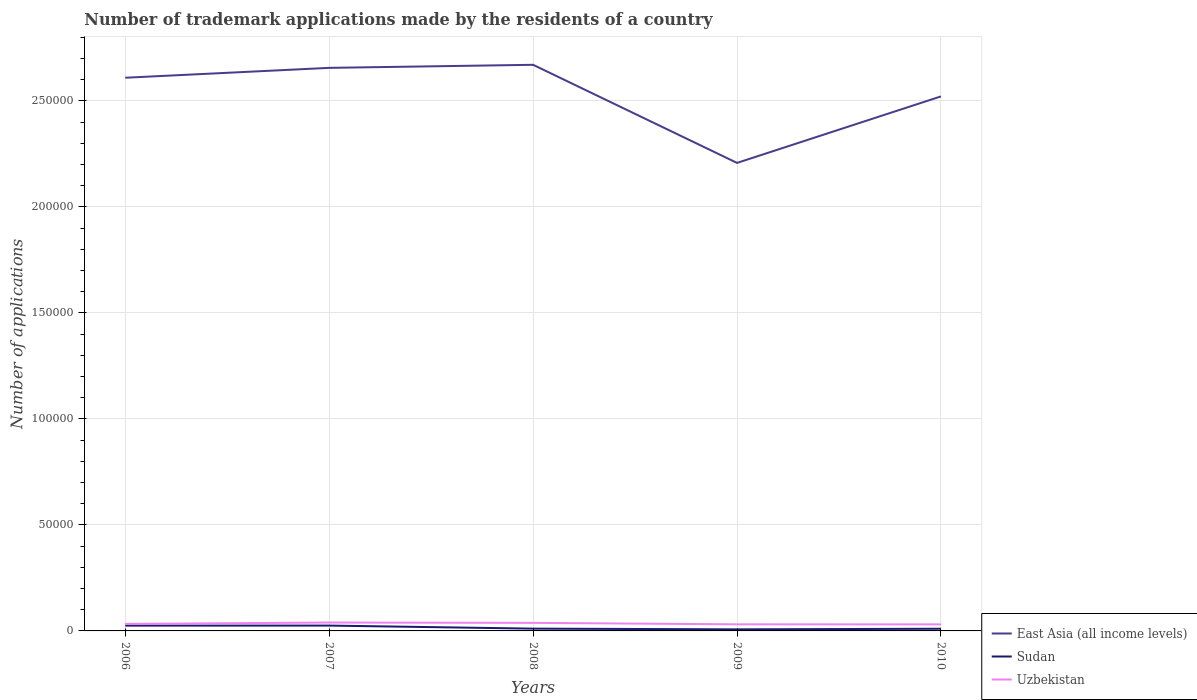Is the number of lines equal to the number of legend labels?
Your answer should be very brief. Yes. Across all years, what is the maximum number of trademark applications made by the residents in Sudan?
Make the answer very short. 743. What is the difference between the highest and the second highest number of trademark applications made by the residents in East Asia (all income levels)?
Ensure brevity in your answer.  4.63e+04. What is the difference between the highest and the lowest number of trademark applications made by the residents in Sudan?
Ensure brevity in your answer.  2. Is the number of trademark applications made by the residents in Sudan strictly greater than the number of trademark applications made by the residents in East Asia (all income levels) over the years?
Offer a terse response. Yes. How many lines are there?
Offer a very short reply. 3. How many years are there in the graph?
Keep it short and to the point. 5. What is the difference between two consecutive major ticks on the Y-axis?
Provide a short and direct response. 5.00e+04. Does the graph contain any zero values?
Your response must be concise. No. Does the graph contain grids?
Your answer should be compact. Yes. Where does the legend appear in the graph?
Offer a very short reply. Bottom right. What is the title of the graph?
Your answer should be very brief. Number of trademark applications made by the residents of a country. Does "Low income" appear as one of the legend labels in the graph?
Keep it short and to the point. No. What is the label or title of the X-axis?
Offer a terse response. Years. What is the label or title of the Y-axis?
Your answer should be very brief. Number of applications. What is the Number of applications of East Asia (all income levels) in 2006?
Keep it short and to the point. 2.61e+05. What is the Number of applications of Sudan in 2006?
Your answer should be compact. 2508. What is the Number of applications in Uzbekistan in 2006?
Provide a short and direct response. 3309. What is the Number of applications in East Asia (all income levels) in 2007?
Keep it short and to the point. 2.66e+05. What is the Number of applications in Sudan in 2007?
Your response must be concise. 2517. What is the Number of applications of Uzbekistan in 2007?
Your answer should be very brief. 3948. What is the Number of applications in East Asia (all income levels) in 2008?
Offer a terse response. 2.67e+05. What is the Number of applications of Sudan in 2008?
Your answer should be very brief. 1075. What is the Number of applications in Uzbekistan in 2008?
Provide a succinct answer. 3803. What is the Number of applications in East Asia (all income levels) in 2009?
Keep it short and to the point. 2.21e+05. What is the Number of applications in Sudan in 2009?
Keep it short and to the point. 743. What is the Number of applications of Uzbekistan in 2009?
Give a very brief answer. 3110. What is the Number of applications of East Asia (all income levels) in 2010?
Give a very brief answer. 2.52e+05. What is the Number of applications of Sudan in 2010?
Offer a terse response. 1025. What is the Number of applications in Uzbekistan in 2010?
Ensure brevity in your answer.  3088. Across all years, what is the maximum Number of applications of East Asia (all income levels)?
Provide a short and direct response. 2.67e+05. Across all years, what is the maximum Number of applications in Sudan?
Your answer should be very brief. 2517. Across all years, what is the maximum Number of applications of Uzbekistan?
Make the answer very short. 3948. Across all years, what is the minimum Number of applications of East Asia (all income levels)?
Provide a succinct answer. 2.21e+05. Across all years, what is the minimum Number of applications in Sudan?
Make the answer very short. 743. Across all years, what is the minimum Number of applications of Uzbekistan?
Keep it short and to the point. 3088. What is the total Number of applications in East Asia (all income levels) in the graph?
Your response must be concise. 1.27e+06. What is the total Number of applications of Sudan in the graph?
Your answer should be very brief. 7868. What is the total Number of applications of Uzbekistan in the graph?
Ensure brevity in your answer.  1.73e+04. What is the difference between the Number of applications of East Asia (all income levels) in 2006 and that in 2007?
Your response must be concise. -4664. What is the difference between the Number of applications in Sudan in 2006 and that in 2007?
Your answer should be very brief. -9. What is the difference between the Number of applications in Uzbekistan in 2006 and that in 2007?
Ensure brevity in your answer.  -639. What is the difference between the Number of applications of East Asia (all income levels) in 2006 and that in 2008?
Ensure brevity in your answer.  -6103. What is the difference between the Number of applications in Sudan in 2006 and that in 2008?
Ensure brevity in your answer.  1433. What is the difference between the Number of applications in Uzbekistan in 2006 and that in 2008?
Provide a short and direct response. -494. What is the difference between the Number of applications in East Asia (all income levels) in 2006 and that in 2009?
Ensure brevity in your answer.  4.02e+04. What is the difference between the Number of applications in Sudan in 2006 and that in 2009?
Offer a terse response. 1765. What is the difference between the Number of applications in Uzbekistan in 2006 and that in 2009?
Keep it short and to the point. 199. What is the difference between the Number of applications in East Asia (all income levels) in 2006 and that in 2010?
Give a very brief answer. 8800. What is the difference between the Number of applications in Sudan in 2006 and that in 2010?
Your response must be concise. 1483. What is the difference between the Number of applications of Uzbekistan in 2006 and that in 2010?
Provide a succinct answer. 221. What is the difference between the Number of applications in East Asia (all income levels) in 2007 and that in 2008?
Your answer should be compact. -1439. What is the difference between the Number of applications of Sudan in 2007 and that in 2008?
Offer a terse response. 1442. What is the difference between the Number of applications in Uzbekistan in 2007 and that in 2008?
Make the answer very short. 145. What is the difference between the Number of applications in East Asia (all income levels) in 2007 and that in 2009?
Your response must be concise. 4.48e+04. What is the difference between the Number of applications of Sudan in 2007 and that in 2009?
Your response must be concise. 1774. What is the difference between the Number of applications of Uzbekistan in 2007 and that in 2009?
Offer a very short reply. 838. What is the difference between the Number of applications in East Asia (all income levels) in 2007 and that in 2010?
Ensure brevity in your answer.  1.35e+04. What is the difference between the Number of applications of Sudan in 2007 and that in 2010?
Your answer should be very brief. 1492. What is the difference between the Number of applications of Uzbekistan in 2007 and that in 2010?
Provide a succinct answer. 860. What is the difference between the Number of applications in East Asia (all income levels) in 2008 and that in 2009?
Your response must be concise. 4.63e+04. What is the difference between the Number of applications in Sudan in 2008 and that in 2009?
Your response must be concise. 332. What is the difference between the Number of applications in Uzbekistan in 2008 and that in 2009?
Provide a succinct answer. 693. What is the difference between the Number of applications of East Asia (all income levels) in 2008 and that in 2010?
Offer a very short reply. 1.49e+04. What is the difference between the Number of applications in Sudan in 2008 and that in 2010?
Your answer should be compact. 50. What is the difference between the Number of applications of Uzbekistan in 2008 and that in 2010?
Offer a terse response. 715. What is the difference between the Number of applications in East Asia (all income levels) in 2009 and that in 2010?
Keep it short and to the point. -3.14e+04. What is the difference between the Number of applications in Sudan in 2009 and that in 2010?
Ensure brevity in your answer.  -282. What is the difference between the Number of applications in Uzbekistan in 2009 and that in 2010?
Your answer should be compact. 22. What is the difference between the Number of applications in East Asia (all income levels) in 2006 and the Number of applications in Sudan in 2007?
Give a very brief answer. 2.58e+05. What is the difference between the Number of applications in East Asia (all income levels) in 2006 and the Number of applications in Uzbekistan in 2007?
Provide a short and direct response. 2.57e+05. What is the difference between the Number of applications in Sudan in 2006 and the Number of applications in Uzbekistan in 2007?
Give a very brief answer. -1440. What is the difference between the Number of applications of East Asia (all income levels) in 2006 and the Number of applications of Sudan in 2008?
Ensure brevity in your answer.  2.60e+05. What is the difference between the Number of applications in East Asia (all income levels) in 2006 and the Number of applications in Uzbekistan in 2008?
Provide a succinct answer. 2.57e+05. What is the difference between the Number of applications in Sudan in 2006 and the Number of applications in Uzbekistan in 2008?
Give a very brief answer. -1295. What is the difference between the Number of applications of East Asia (all income levels) in 2006 and the Number of applications of Sudan in 2009?
Provide a short and direct response. 2.60e+05. What is the difference between the Number of applications in East Asia (all income levels) in 2006 and the Number of applications in Uzbekistan in 2009?
Offer a very short reply. 2.58e+05. What is the difference between the Number of applications of Sudan in 2006 and the Number of applications of Uzbekistan in 2009?
Provide a short and direct response. -602. What is the difference between the Number of applications in East Asia (all income levels) in 2006 and the Number of applications in Sudan in 2010?
Offer a terse response. 2.60e+05. What is the difference between the Number of applications in East Asia (all income levels) in 2006 and the Number of applications in Uzbekistan in 2010?
Ensure brevity in your answer.  2.58e+05. What is the difference between the Number of applications of Sudan in 2006 and the Number of applications of Uzbekistan in 2010?
Provide a short and direct response. -580. What is the difference between the Number of applications of East Asia (all income levels) in 2007 and the Number of applications of Sudan in 2008?
Ensure brevity in your answer.  2.65e+05. What is the difference between the Number of applications in East Asia (all income levels) in 2007 and the Number of applications in Uzbekistan in 2008?
Give a very brief answer. 2.62e+05. What is the difference between the Number of applications in Sudan in 2007 and the Number of applications in Uzbekistan in 2008?
Provide a short and direct response. -1286. What is the difference between the Number of applications of East Asia (all income levels) in 2007 and the Number of applications of Sudan in 2009?
Offer a terse response. 2.65e+05. What is the difference between the Number of applications of East Asia (all income levels) in 2007 and the Number of applications of Uzbekistan in 2009?
Your response must be concise. 2.62e+05. What is the difference between the Number of applications of Sudan in 2007 and the Number of applications of Uzbekistan in 2009?
Offer a very short reply. -593. What is the difference between the Number of applications of East Asia (all income levels) in 2007 and the Number of applications of Sudan in 2010?
Offer a very short reply. 2.65e+05. What is the difference between the Number of applications of East Asia (all income levels) in 2007 and the Number of applications of Uzbekistan in 2010?
Your answer should be compact. 2.62e+05. What is the difference between the Number of applications of Sudan in 2007 and the Number of applications of Uzbekistan in 2010?
Make the answer very short. -571. What is the difference between the Number of applications of East Asia (all income levels) in 2008 and the Number of applications of Sudan in 2009?
Keep it short and to the point. 2.66e+05. What is the difference between the Number of applications in East Asia (all income levels) in 2008 and the Number of applications in Uzbekistan in 2009?
Make the answer very short. 2.64e+05. What is the difference between the Number of applications of Sudan in 2008 and the Number of applications of Uzbekistan in 2009?
Provide a short and direct response. -2035. What is the difference between the Number of applications in East Asia (all income levels) in 2008 and the Number of applications in Sudan in 2010?
Provide a succinct answer. 2.66e+05. What is the difference between the Number of applications in East Asia (all income levels) in 2008 and the Number of applications in Uzbekistan in 2010?
Provide a short and direct response. 2.64e+05. What is the difference between the Number of applications of Sudan in 2008 and the Number of applications of Uzbekistan in 2010?
Keep it short and to the point. -2013. What is the difference between the Number of applications in East Asia (all income levels) in 2009 and the Number of applications in Sudan in 2010?
Offer a very short reply. 2.20e+05. What is the difference between the Number of applications of East Asia (all income levels) in 2009 and the Number of applications of Uzbekistan in 2010?
Offer a very short reply. 2.18e+05. What is the difference between the Number of applications in Sudan in 2009 and the Number of applications in Uzbekistan in 2010?
Offer a terse response. -2345. What is the average Number of applications in East Asia (all income levels) per year?
Ensure brevity in your answer.  2.53e+05. What is the average Number of applications in Sudan per year?
Your answer should be very brief. 1573.6. What is the average Number of applications of Uzbekistan per year?
Make the answer very short. 3451.6. In the year 2006, what is the difference between the Number of applications of East Asia (all income levels) and Number of applications of Sudan?
Make the answer very short. 2.58e+05. In the year 2006, what is the difference between the Number of applications in East Asia (all income levels) and Number of applications in Uzbekistan?
Make the answer very short. 2.58e+05. In the year 2006, what is the difference between the Number of applications of Sudan and Number of applications of Uzbekistan?
Give a very brief answer. -801. In the year 2007, what is the difference between the Number of applications of East Asia (all income levels) and Number of applications of Sudan?
Your response must be concise. 2.63e+05. In the year 2007, what is the difference between the Number of applications in East Asia (all income levels) and Number of applications in Uzbekistan?
Provide a succinct answer. 2.62e+05. In the year 2007, what is the difference between the Number of applications of Sudan and Number of applications of Uzbekistan?
Your answer should be compact. -1431. In the year 2008, what is the difference between the Number of applications in East Asia (all income levels) and Number of applications in Sudan?
Your response must be concise. 2.66e+05. In the year 2008, what is the difference between the Number of applications in East Asia (all income levels) and Number of applications in Uzbekistan?
Your answer should be compact. 2.63e+05. In the year 2008, what is the difference between the Number of applications in Sudan and Number of applications in Uzbekistan?
Provide a short and direct response. -2728. In the year 2009, what is the difference between the Number of applications in East Asia (all income levels) and Number of applications in Sudan?
Offer a terse response. 2.20e+05. In the year 2009, what is the difference between the Number of applications of East Asia (all income levels) and Number of applications of Uzbekistan?
Provide a succinct answer. 2.18e+05. In the year 2009, what is the difference between the Number of applications in Sudan and Number of applications in Uzbekistan?
Give a very brief answer. -2367. In the year 2010, what is the difference between the Number of applications in East Asia (all income levels) and Number of applications in Sudan?
Provide a succinct answer. 2.51e+05. In the year 2010, what is the difference between the Number of applications in East Asia (all income levels) and Number of applications in Uzbekistan?
Provide a short and direct response. 2.49e+05. In the year 2010, what is the difference between the Number of applications in Sudan and Number of applications in Uzbekistan?
Your answer should be compact. -2063. What is the ratio of the Number of applications in East Asia (all income levels) in 2006 to that in 2007?
Your answer should be compact. 0.98. What is the ratio of the Number of applications of Uzbekistan in 2006 to that in 2007?
Your answer should be very brief. 0.84. What is the ratio of the Number of applications in East Asia (all income levels) in 2006 to that in 2008?
Give a very brief answer. 0.98. What is the ratio of the Number of applications of Sudan in 2006 to that in 2008?
Your answer should be compact. 2.33. What is the ratio of the Number of applications of Uzbekistan in 2006 to that in 2008?
Offer a very short reply. 0.87. What is the ratio of the Number of applications in East Asia (all income levels) in 2006 to that in 2009?
Make the answer very short. 1.18. What is the ratio of the Number of applications of Sudan in 2006 to that in 2009?
Provide a succinct answer. 3.38. What is the ratio of the Number of applications in Uzbekistan in 2006 to that in 2009?
Your answer should be compact. 1.06. What is the ratio of the Number of applications of East Asia (all income levels) in 2006 to that in 2010?
Keep it short and to the point. 1.03. What is the ratio of the Number of applications in Sudan in 2006 to that in 2010?
Your answer should be very brief. 2.45. What is the ratio of the Number of applications of Uzbekistan in 2006 to that in 2010?
Provide a succinct answer. 1.07. What is the ratio of the Number of applications of Sudan in 2007 to that in 2008?
Provide a succinct answer. 2.34. What is the ratio of the Number of applications of Uzbekistan in 2007 to that in 2008?
Your answer should be very brief. 1.04. What is the ratio of the Number of applications of East Asia (all income levels) in 2007 to that in 2009?
Offer a very short reply. 1.2. What is the ratio of the Number of applications in Sudan in 2007 to that in 2009?
Provide a succinct answer. 3.39. What is the ratio of the Number of applications in Uzbekistan in 2007 to that in 2009?
Keep it short and to the point. 1.27. What is the ratio of the Number of applications of East Asia (all income levels) in 2007 to that in 2010?
Your response must be concise. 1.05. What is the ratio of the Number of applications in Sudan in 2007 to that in 2010?
Your answer should be compact. 2.46. What is the ratio of the Number of applications of Uzbekistan in 2007 to that in 2010?
Provide a succinct answer. 1.28. What is the ratio of the Number of applications of East Asia (all income levels) in 2008 to that in 2009?
Provide a succinct answer. 1.21. What is the ratio of the Number of applications of Sudan in 2008 to that in 2009?
Keep it short and to the point. 1.45. What is the ratio of the Number of applications in Uzbekistan in 2008 to that in 2009?
Offer a very short reply. 1.22. What is the ratio of the Number of applications in East Asia (all income levels) in 2008 to that in 2010?
Give a very brief answer. 1.06. What is the ratio of the Number of applications of Sudan in 2008 to that in 2010?
Offer a terse response. 1.05. What is the ratio of the Number of applications of Uzbekistan in 2008 to that in 2010?
Make the answer very short. 1.23. What is the ratio of the Number of applications in East Asia (all income levels) in 2009 to that in 2010?
Your response must be concise. 0.88. What is the ratio of the Number of applications in Sudan in 2009 to that in 2010?
Offer a terse response. 0.72. What is the ratio of the Number of applications of Uzbekistan in 2009 to that in 2010?
Offer a very short reply. 1.01. What is the difference between the highest and the second highest Number of applications in East Asia (all income levels)?
Your answer should be very brief. 1439. What is the difference between the highest and the second highest Number of applications of Sudan?
Your answer should be compact. 9. What is the difference between the highest and the second highest Number of applications of Uzbekistan?
Your answer should be very brief. 145. What is the difference between the highest and the lowest Number of applications of East Asia (all income levels)?
Provide a short and direct response. 4.63e+04. What is the difference between the highest and the lowest Number of applications in Sudan?
Make the answer very short. 1774. What is the difference between the highest and the lowest Number of applications of Uzbekistan?
Keep it short and to the point. 860. 